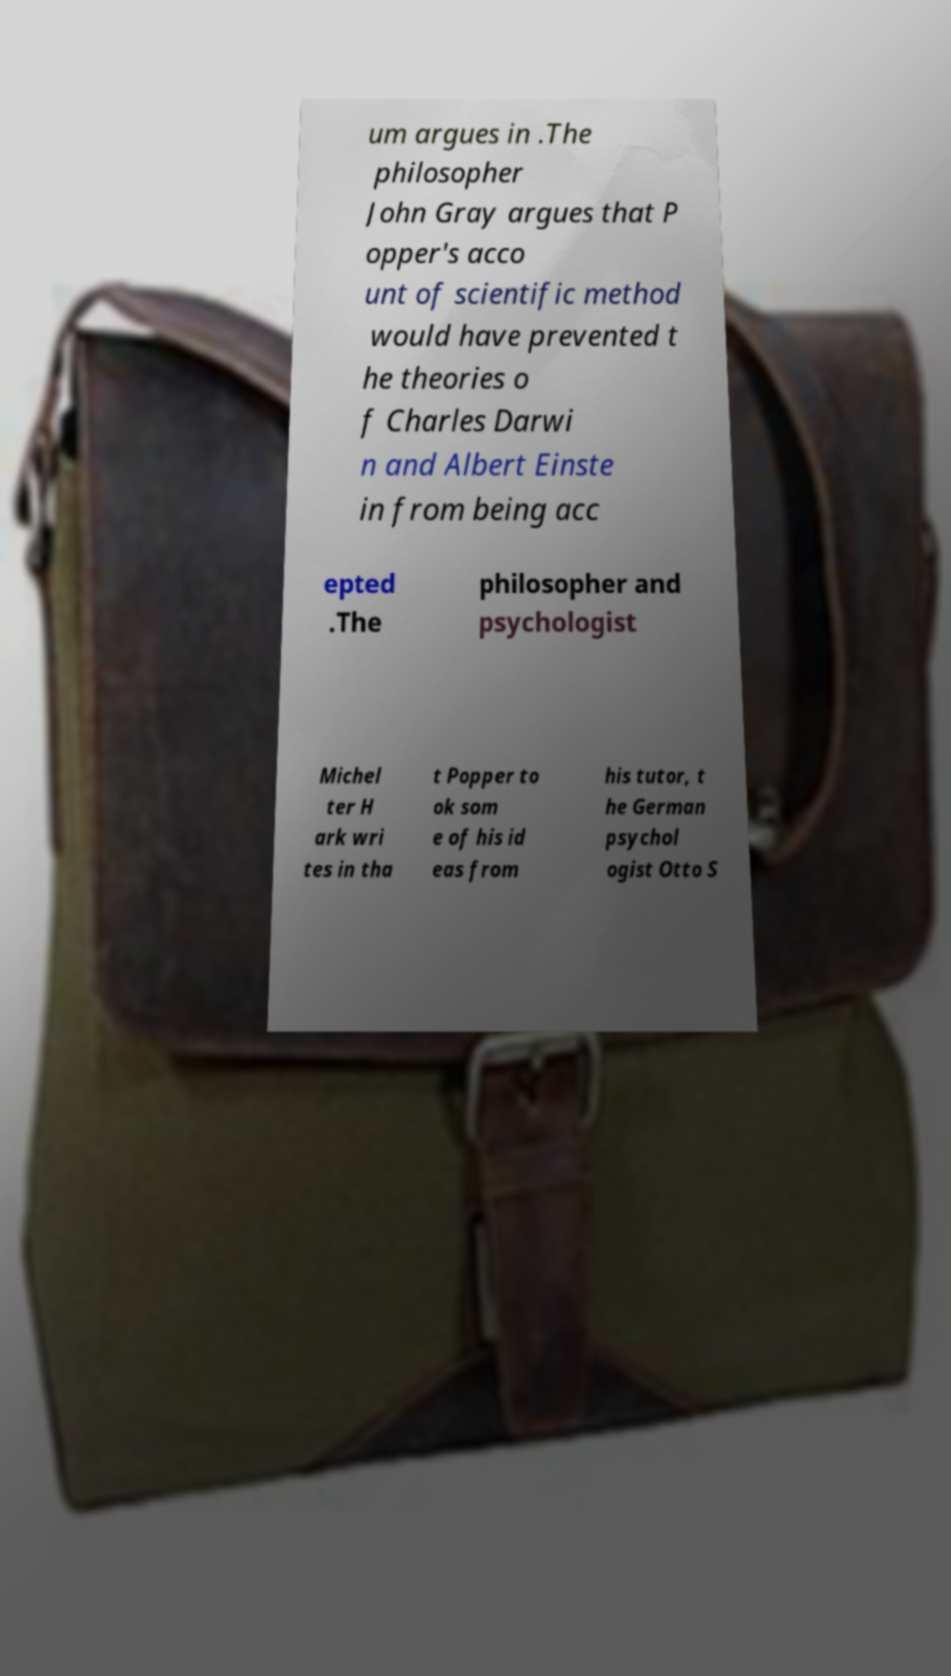Could you assist in decoding the text presented in this image and type it out clearly? um argues in .The philosopher John Gray argues that P opper's acco unt of scientific method would have prevented t he theories o f Charles Darwi n and Albert Einste in from being acc epted .The philosopher and psychologist Michel ter H ark wri tes in tha t Popper to ok som e of his id eas from his tutor, t he German psychol ogist Otto S 